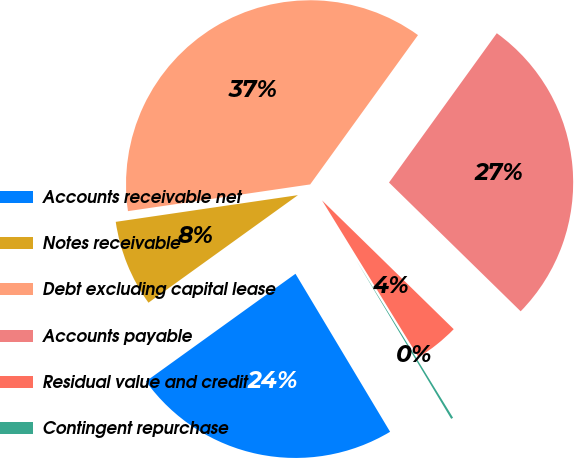Convert chart to OTSL. <chart><loc_0><loc_0><loc_500><loc_500><pie_chart><fcel>Accounts receivable net<fcel>Notes receivable<fcel>Debt excluding capital lease<fcel>Accounts payable<fcel>Residual value and credit<fcel>Contingent repurchase<nl><fcel>23.66%<fcel>7.61%<fcel>37.27%<fcel>27.37%<fcel>3.9%<fcel>0.19%<nl></chart> 